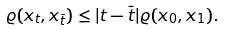Convert formula to latex. <formula><loc_0><loc_0><loc_500><loc_500>\varrho ( x _ { t } , x _ { \bar { t } } ) \leq | t - \bar { t } | \varrho ( x _ { 0 } , x _ { 1 } ) .</formula> 